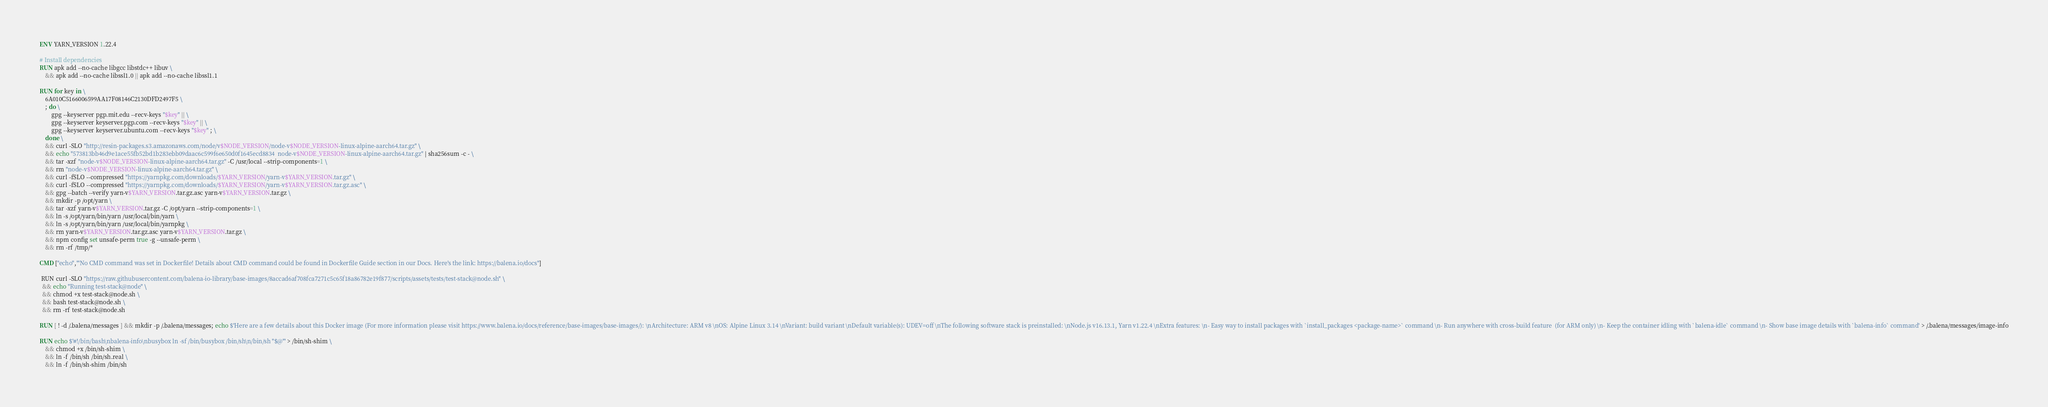Convert code to text. <code><loc_0><loc_0><loc_500><loc_500><_Dockerfile_>ENV YARN_VERSION 1.22.4

# Install dependencies
RUN apk add --no-cache libgcc libstdc++ libuv \
	&& apk add --no-cache libssl1.0 || apk add --no-cache libssl1.1

RUN for key in \
	6A010C5166006599AA17F08146C2130DFD2497F5 \
	; do \
		gpg --keyserver pgp.mit.edu --recv-keys "$key" || \
		gpg --keyserver keyserver.pgp.com --recv-keys "$key" || \
		gpg --keyserver keyserver.ubuntu.com --recv-keys "$key" ; \
	done \
	&& curl -SLO "http://resin-packages.s3.amazonaws.com/node/v$NODE_VERSION/node-v$NODE_VERSION-linux-alpine-aarch64.tar.gz" \
	&& echo "573813bb46d9e1ace55fb52bd1b283ebb09daac6c599f6e650d0f1645ecd8834  node-v$NODE_VERSION-linux-alpine-aarch64.tar.gz" | sha256sum -c - \
	&& tar -xzf "node-v$NODE_VERSION-linux-alpine-aarch64.tar.gz" -C /usr/local --strip-components=1 \
	&& rm "node-v$NODE_VERSION-linux-alpine-aarch64.tar.gz" \
	&& curl -fSLO --compressed "https://yarnpkg.com/downloads/$YARN_VERSION/yarn-v$YARN_VERSION.tar.gz" \
	&& curl -fSLO --compressed "https://yarnpkg.com/downloads/$YARN_VERSION/yarn-v$YARN_VERSION.tar.gz.asc" \
	&& gpg --batch --verify yarn-v$YARN_VERSION.tar.gz.asc yarn-v$YARN_VERSION.tar.gz \
	&& mkdir -p /opt/yarn \
	&& tar -xzf yarn-v$YARN_VERSION.tar.gz -C /opt/yarn --strip-components=1 \
	&& ln -s /opt/yarn/bin/yarn /usr/local/bin/yarn \
	&& ln -s /opt/yarn/bin/yarn /usr/local/bin/yarnpkg \
	&& rm yarn-v$YARN_VERSION.tar.gz.asc yarn-v$YARN_VERSION.tar.gz \
	&& npm config set unsafe-perm true -g --unsafe-perm \
	&& rm -rf /tmp/*

CMD ["echo","'No CMD command was set in Dockerfile! Details about CMD command could be found in Dockerfile Guide section in our Docs. Here's the link: https://balena.io/docs"]

 RUN curl -SLO "https://raw.githubusercontent.com/balena-io-library/base-images/8accad6af708fca7271c5c65f18a86782e19f877/scripts/assets/tests/test-stack@node.sh" \
  && echo "Running test-stack@node" \
  && chmod +x test-stack@node.sh \
  && bash test-stack@node.sh \
  && rm -rf test-stack@node.sh 

RUN [ ! -d /.balena/messages ] && mkdir -p /.balena/messages; echo $'Here are a few details about this Docker image (For more information please visit https://www.balena.io/docs/reference/base-images/base-images/): \nArchitecture: ARM v8 \nOS: Alpine Linux 3.14 \nVariant: build variant \nDefault variable(s): UDEV=off \nThe following software stack is preinstalled: \nNode.js v16.13.1, Yarn v1.22.4 \nExtra features: \n- Easy way to install packages with `install_packages <package-name>` command \n- Run anywhere with cross-build feature  (for ARM only) \n- Keep the container idling with `balena-idle` command \n- Show base image details with `balena-info` command' > /.balena/messages/image-info

RUN echo $'#!/bin/bash\nbalena-info\nbusybox ln -sf /bin/busybox /bin/sh\n/bin/sh "$@"' > /bin/sh-shim \
	&& chmod +x /bin/sh-shim \
	&& ln -f /bin/sh /bin/sh.real \
	&& ln -f /bin/sh-shim /bin/sh</code> 